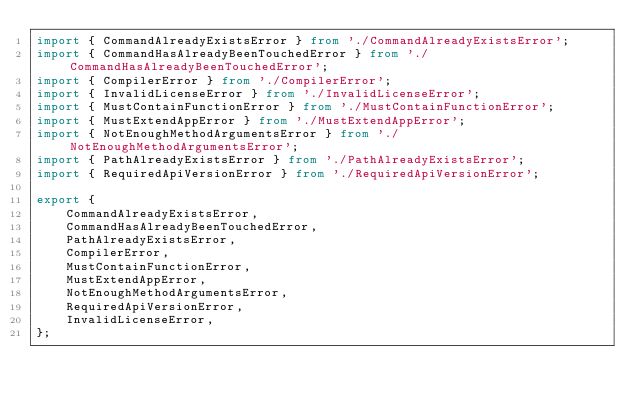Convert code to text. <code><loc_0><loc_0><loc_500><loc_500><_TypeScript_>import { CommandAlreadyExistsError } from './CommandAlreadyExistsError';
import { CommandHasAlreadyBeenTouchedError } from './CommandHasAlreadyBeenTouchedError';
import { CompilerError } from './CompilerError';
import { InvalidLicenseError } from './InvalidLicenseError';
import { MustContainFunctionError } from './MustContainFunctionError';
import { MustExtendAppError } from './MustExtendAppError';
import { NotEnoughMethodArgumentsError } from './NotEnoughMethodArgumentsError';
import { PathAlreadyExistsError } from './PathAlreadyExistsError';
import { RequiredApiVersionError } from './RequiredApiVersionError';

export {
    CommandAlreadyExistsError,
    CommandHasAlreadyBeenTouchedError,
    PathAlreadyExistsError,
    CompilerError,
    MustContainFunctionError,
    MustExtendAppError,
    NotEnoughMethodArgumentsError,
    RequiredApiVersionError,
    InvalidLicenseError,
};
</code> 